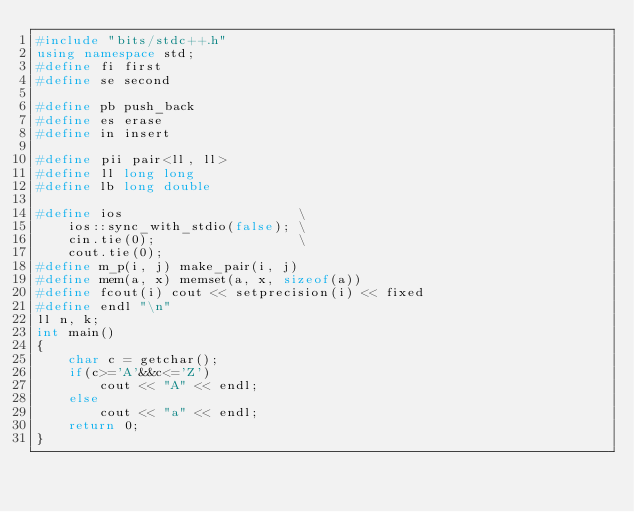<code> <loc_0><loc_0><loc_500><loc_500><_C++_>#include "bits/stdc++.h"
using namespace std;
#define fi first
#define se second

#define pb push_back
#define es erase
#define in insert

#define pii pair<ll, ll>
#define ll long long
#define lb long double

#define ios                      \
    ios::sync_with_stdio(false); \
    cin.tie(0);                  \
    cout.tie(0);
#define m_p(i, j) make_pair(i, j)
#define mem(a, x) memset(a, x, sizeof(a))
#define fcout(i) cout << setprecision(i) << fixed
#define endl "\n"
ll n, k;
int main()
{
    char c = getchar();
    if(c>='A'&&c<='Z')
        cout << "A" << endl;
    else
        cout << "a" << endl;
    return 0;
}</code> 